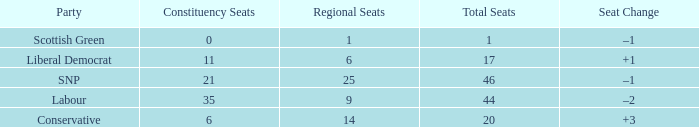What is the full number of Total Seats with a constituency seat number bigger than 0 with the Liberal Democrat party, and the Regional seat number is smaller than 6? None. 